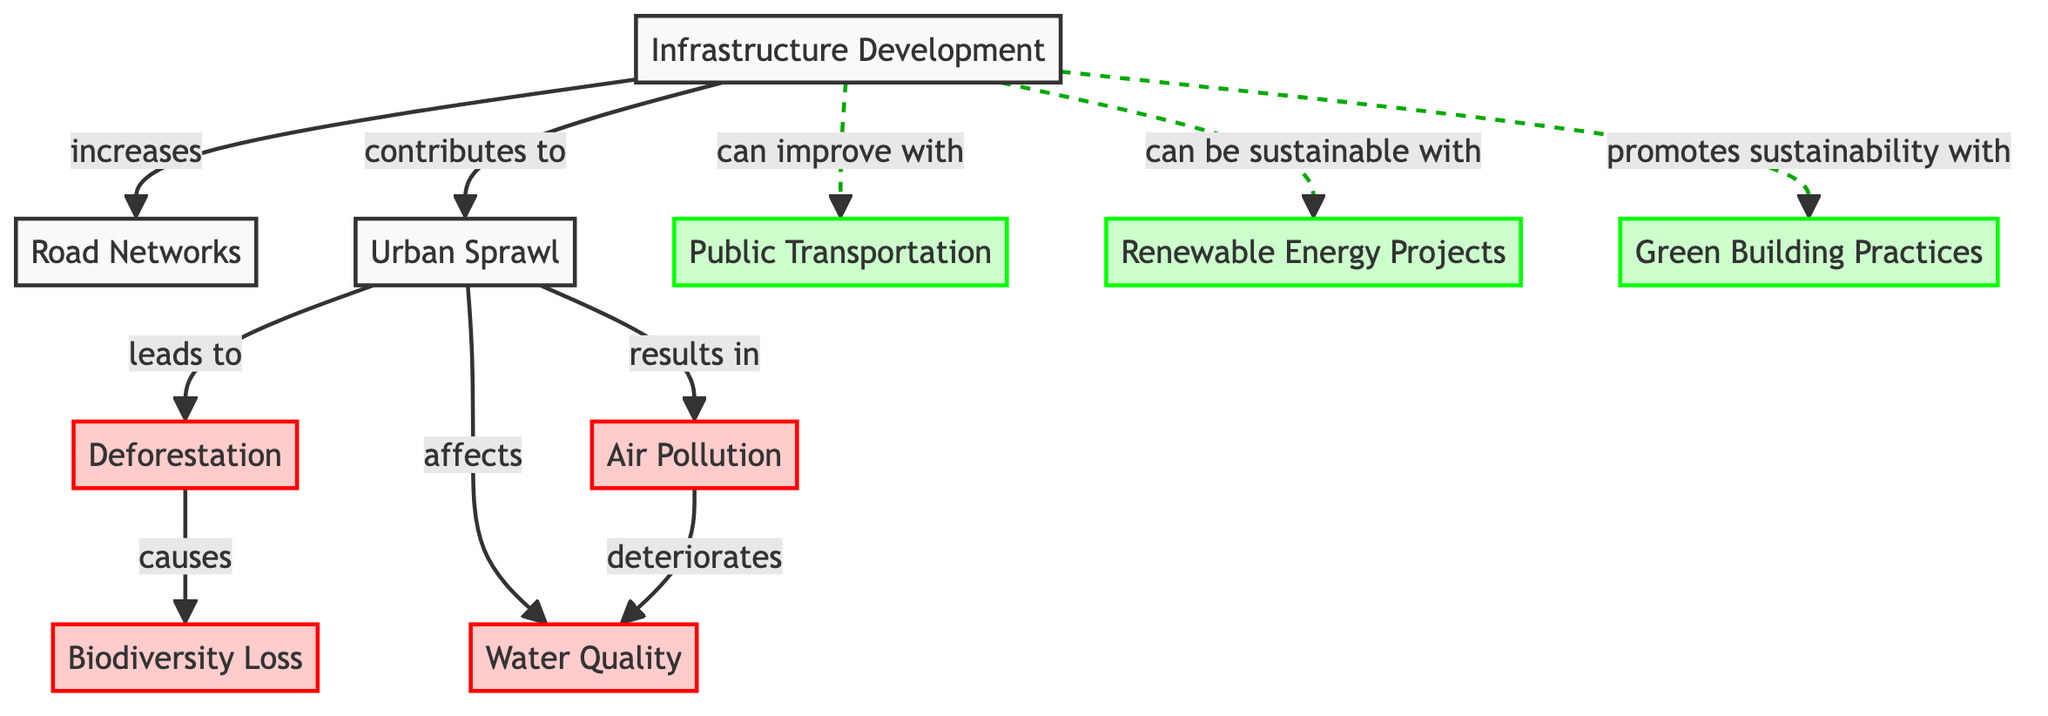What is the total number of nodes in the diagram? The diagram lists the following nodes: Infrastructure Development, Road Networks, Urban Sprawl, Deforestation, Air Pollution, Water Quality, Biodiversity Loss, Public Transportation, Renewable Energy Projects, and Green Building Practices. Counting these gives a total of 10 nodes.
Answer: 10 What does Infrastructure Development increase? The edge leading from Infrastructure Development indicates that it increases Road Networks, as denoted by the label "increases" on the connecting line in the diagram.
Answer: Road Networks Which environmental issue does Urban Sprawl lead to? The diagram shows that Urban Sprawl leads to Deforestation, as indicated by the edge connection with the label "leads to." This shows a direct relationship from Urban Sprawl to Deforestation.
Answer: Deforestation How many impacts are associated with Urban Sprawl? Urban Sprawl is directly connected to three specific impacts in the diagram: Deforestation, Air Pollution, and Water Quality. Each of these relationships is represented by edges stemming from the Urban Sprawl node, pointing to environmental consequences. Counting these, we conclude that there are three impacts associated with Urban Sprawl.
Answer: 3 Which solution can improve Infrastructure Development? The diagram indicates that Public Transportation can improve Infrastructure Development, which is shown by the dashed edge labeled "can improve with." This denotes potential benefit derived from integrating Public Transportation into Infrastructure Development.
Answer: Public Transportation What is one environmental consequence of Air Pollution? The diagram indicates that Air Pollution deteriorates Water Quality, as shown by the label "deteriorates" on the connecting edge from Air Pollution to Water Quality. This signifies a negative consequence flowing from one issue to another.
Answer: Water Quality What contributes to Urban Sprawl? The diagram directly states that Infrastructure Development contributes to Urban Sprawl, with the edge labeled "contributes to" connecting the two nodes. This indicates that the growth in infrastructure serves as a catalyst for urban expansion.
Answer: Infrastructure Development What causes Biodiversity Loss? Deforestation is shown to cause Biodiversity Loss in the diagram, as the edge from Deforestation states "causes." This relationship illustrates a direct correlation where the act of deforestation impacts biodiversity.
Answer: Deforestation Which two projects can make Infrastructure Development sustainable? The diagram indicates two specific projects that can make Infrastructure Development sustainable: Renewable Energy Projects and Green Building Practices. Both are connected to the Infrastructure Development node via dashed edges labeled "can be sustainable with" and "promotes sustainability with," respectively.
Answer: Renewable Energy Projects, Green Building Practices 